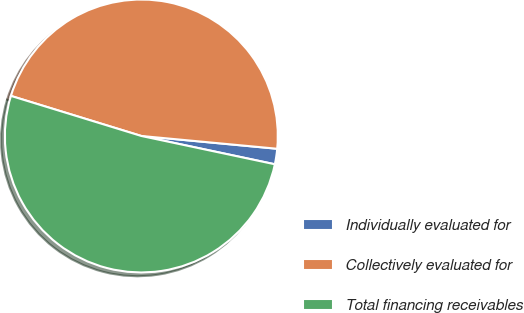Convert chart. <chart><loc_0><loc_0><loc_500><loc_500><pie_chart><fcel>Individually evaluated for<fcel>Collectively evaluated for<fcel>Total financing receivables<nl><fcel>1.83%<fcel>46.75%<fcel>51.42%<nl></chart> 